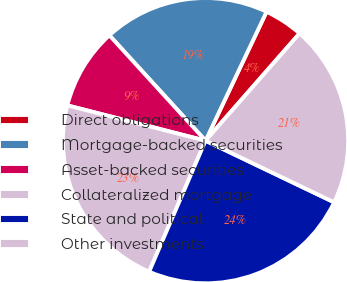Convert chart. <chart><loc_0><loc_0><loc_500><loc_500><pie_chart><fcel>Direct obligations<fcel>Mortgage-backed securities<fcel>Asset-backed securities<fcel>Collateralized mortgage<fcel>State and political<fcel>Other investments<nl><fcel>4.42%<fcel>18.81%<fcel>9.25%<fcel>22.51%<fcel>24.36%<fcel>20.66%<nl></chart> 